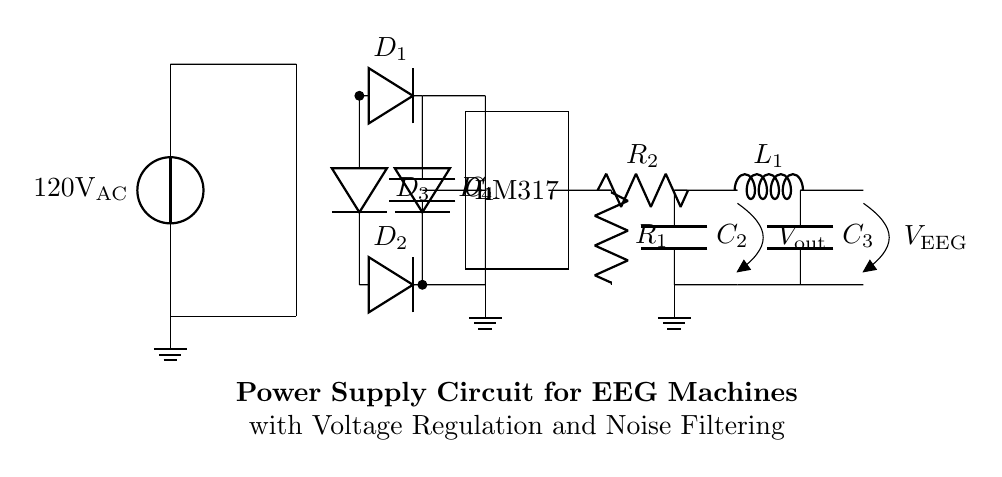What is the input voltage for the circuit? The input voltage is 120 volts AC, as indicated by the voltage source label on the left side of the circuit diagram.
Answer: 120 volts AC What type of voltage regulation component is used? The component used for voltage regulation is an LM317, denoted by the rectangular box labeled LM317 in the circuit.
Answer: LM317 What does capacitor C1 do in this circuit? Capacitor C1 is used for smoothing the rectified output voltage from the diode bridge, which helps reduce voltage fluctuations and ripples in the DC output.
Answer: Smoothing How many diodes are present in the rectifier section? There are four diodes labeled D1, D2, D3, and D4 in the rectifier section, which indicates that this circuit uses a full-wave rectifier configuration.
Answer: Four What is the purpose of the inductor L1 in the circuit? Inductor L1, along with capacitor C3, forms a low-pass filter that helps reduce high-frequency noise in the final output voltage, providing a clean DC signal for the EEG machine.
Answer: Noise filtering What is the output voltage label in the circuit? The output voltage label for the final output of the circuit is V EEG, which signifies that it is the voltage specifically meant for the EEG machine.
Answer: V EEG What two resistors are present in the voltage regulation section? The two resistors present are labeled R1 and R2, which help set the output voltage by dividing the voltage in the regulation section of the circuit.
Answer: R1 and R2 